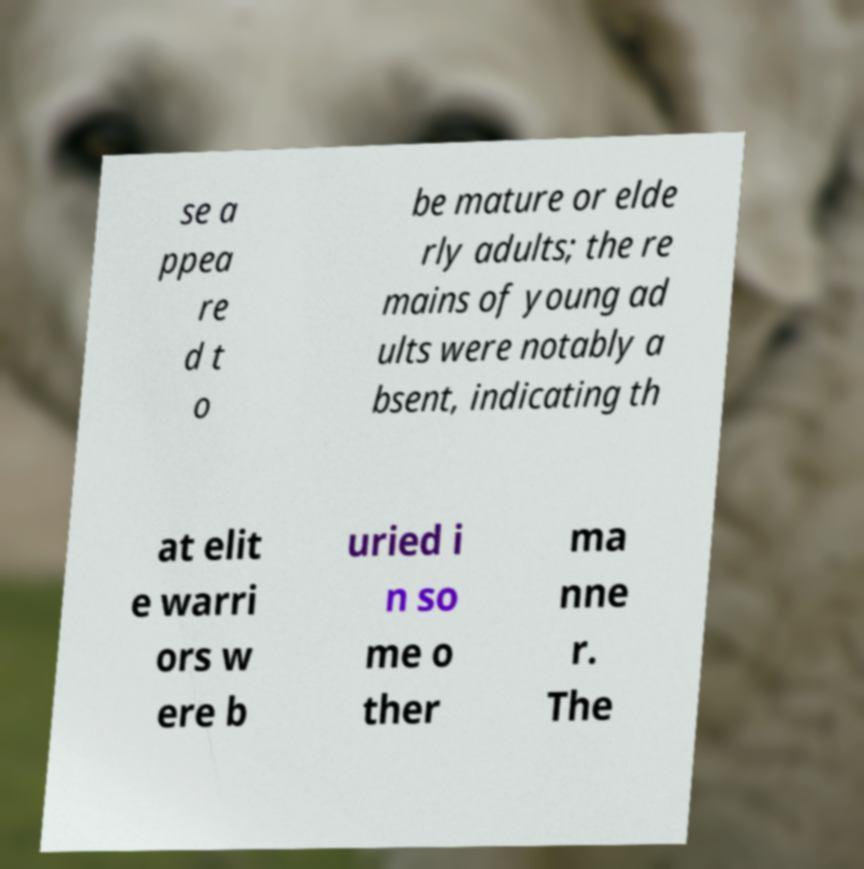Please identify and transcribe the text found in this image. se a ppea re d t o be mature or elde rly adults; the re mains of young ad ults were notably a bsent, indicating th at elit e warri ors w ere b uried i n so me o ther ma nne r. The 